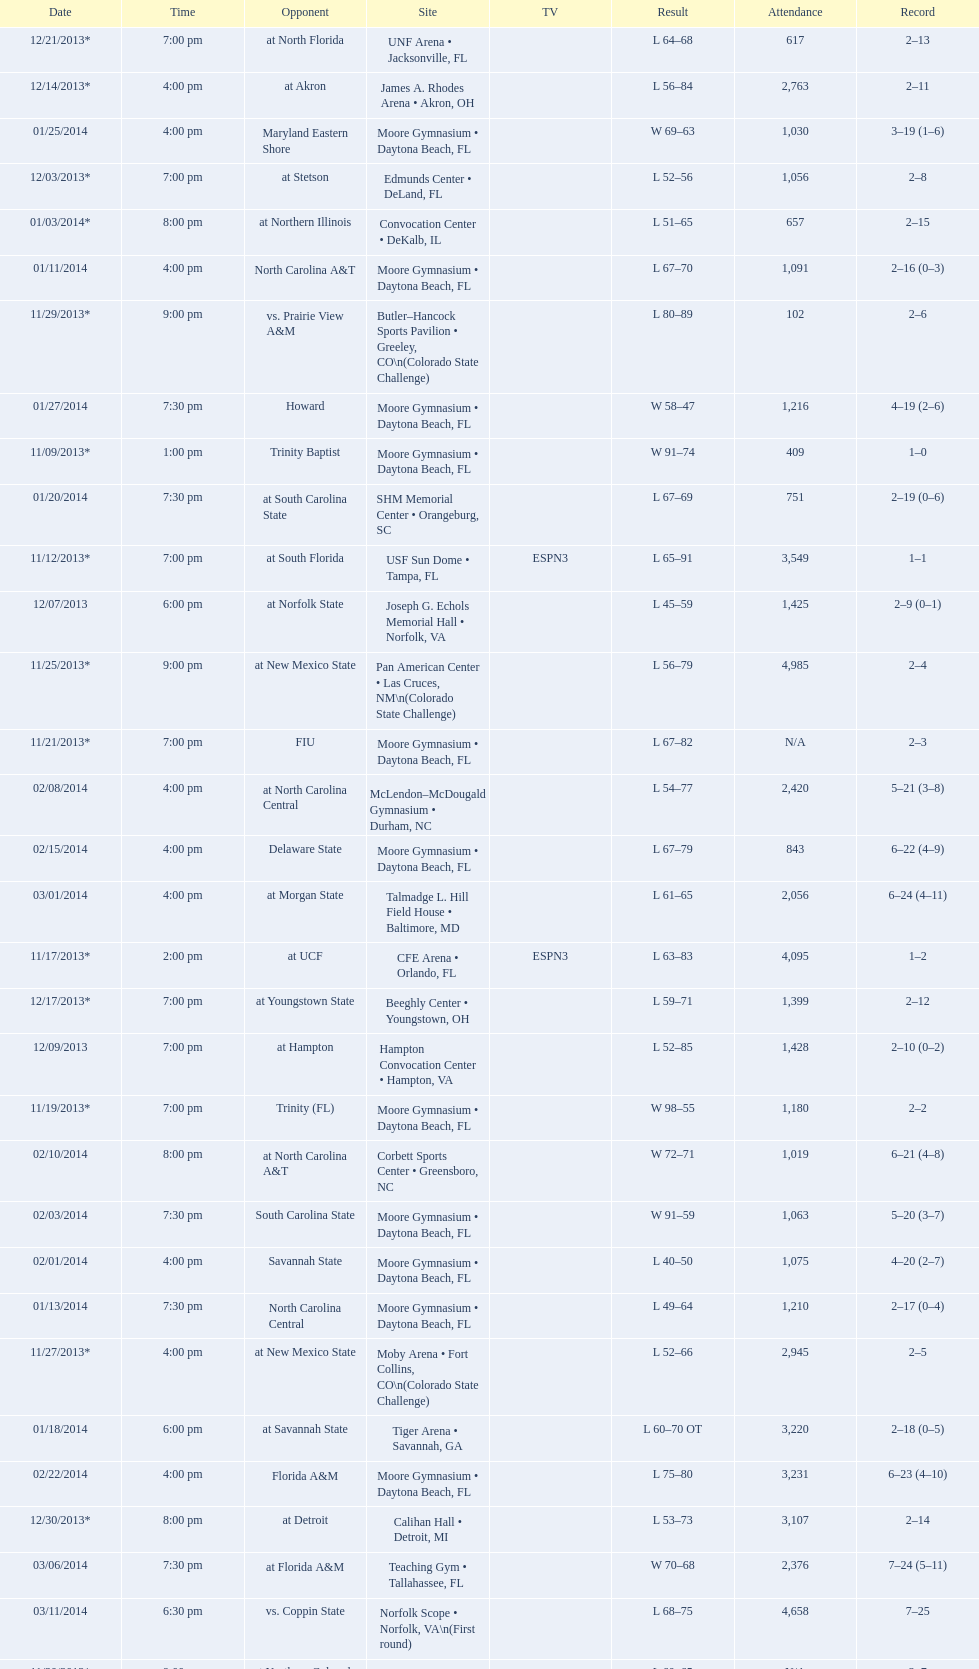What is the total attendance on 11/09/2013? 409. Help me parse the entirety of this table. {'header': ['Date', 'Time', 'Opponent', 'Site', 'TV', 'Result', 'Attendance', 'Record'], 'rows': [['12/21/2013*', '7:00 pm', 'at\xa0North Florida', 'UNF Arena • Jacksonville, FL', '', 'L\xa064–68', '617', '2–13'], ['12/14/2013*', '4:00 pm', 'at\xa0Akron', 'James A. Rhodes Arena • Akron, OH', '', 'L\xa056–84', '2,763', '2–11'], ['01/25/2014', '4:00 pm', 'Maryland Eastern Shore', 'Moore Gymnasium • Daytona Beach, FL', '', 'W\xa069–63', '1,030', '3–19 (1–6)'], ['12/03/2013*', '7:00 pm', 'at\xa0Stetson', 'Edmunds Center • DeLand, FL', '', 'L\xa052–56', '1,056', '2–8'], ['01/03/2014*', '8:00 pm', 'at\xa0Northern Illinois', 'Convocation Center • DeKalb, IL', '', 'L\xa051–65', '657', '2–15'], ['01/11/2014', '4:00 pm', 'North Carolina A&T', 'Moore Gymnasium • Daytona Beach, FL', '', 'L\xa067–70', '1,091', '2–16 (0–3)'], ['11/29/2013*', '9:00 pm', 'vs.\xa0Prairie View A&M', 'Butler–Hancock Sports Pavilion • Greeley, CO\\n(Colorado State Challenge)', '', 'L\xa080–89', '102', '2–6'], ['01/27/2014', '7:30 pm', 'Howard', 'Moore Gymnasium • Daytona Beach, FL', '', 'W\xa058–47', '1,216', '4–19 (2–6)'], ['11/09/2013*', '1:00 pm', 'Trinity Baptist', 'Moore Gymnasium • Daytona Beach, FL', '', 'W\xa091–74', '409', '1–0'], ['01/20/2014', '7:30 pm', 'at\xa0South Carolina State', 'SHM Memorial Center • Orangeburg, SC', '', 'L\xa067–69', '751', '2–19 (0–6)'], ['11/12/2013*', '7:00 pm', 'at\xa0South Florida', 'USF Sun Dome • Tampa, FL', 'ESPN3', 'L\xa065–91', '3,549', '1–1'], ['12/07/2013', '6:00 pm', 'at\xa0Norfolk State', 'Joseph G. Echols Memorial Hall • Norfolk, VA', '', 'L\xa045–59', '1,425', '2–9 (0–1)'], ['11/25/2013*', '9:00 pm', 'at\xa0New Mexico State', 'Pan American Center • Las Cruces, NM\\n(Colorado State Challenge)', '', 'L\xa056–79', '4,985', '2–4'], ['11/21/2013*', '7:00 pm', 'FIU', 'Moore Gymnasium • Daytona Beach, FL', '', 'L\xa067–82', 'N/A', '2–3'], ['02/08/2014', '4:00 pm', 'at\xa0North Carolina Central', 'McLendon–McDougald Gymnasium • Durham, NC', '', 'L\xa054–77', '2,420', '5–21 (3–8)'], ['02/15/2014', '4:00 pm', 'Delaware State', 'Moore Gymnasium • Daytona Beach, FL', '', 'L\xa067–79', '843', '6–22 (4–9)'], ['03/01/2014', '4:00 pm', 'at\xa0Morgan State', 'Talmadge L. Hill Field House • Baltimore, MD', '', 'L\xa061–65', '2,056', '6–24 (4–11)'], ['11/17/2013*', '2:00 pm', 'at\xa0UCF', 'CFE Arena • Orlando, FL', 'ESPN3', 'L\xa063–83', '4,095', '1–2'], ['12/17/2013*', '7:00 pm', 'at\xa0Youngstown State', 'Beeghly Center • Youngstown, OH', '', 'L\xa059–71', '1,399', '2–12'], ['12/09/2013', '7:00 pm', 'at\xa0Hampton', 'Hampton Convocation Center • Hampton, VA', '', 'L\xa052–85', '1,428', '2–10 (0–2)'], ['11/19/2013*', '7:00 pm', 'Trinity (FL)', 'Moore Gymnasium • Daytona Beach, FL', '', 'W\xa098–55', '1,180', '2–2'], ['02/10/2014', '8:00 pm', 'at\xa0North Carolina A&T', 'Corbett Sports Center • Greensboro, NC', '', 'W\xa072–71', '1,019', '6–21 (4–8)'], ['02/03/2014', '7:30 pm', 'South Carolina State', 'Moore Gymnasium • Daytona Beach, FL', '', 'W\xa091–59', '1,063', '5–20 (3–7)'], ['02/01/2014', '4:00 pm', 'Savannah State', 'Moore Gymnasium • Daytona Beach, FL', '', 'L\xa040–50', '1,075', '4–20 (2–7)'], ['01/13/2014', '7:30 pm', 'North Carolina Central', 'Moore Gymnasium • Daytona Beach, FL', '', 'L\xa049–64', '1,210', '2–17 (0–4)'], ['11/27/2013*', '4:00 pm', 'at\xa0New Mexico State', 'Moby Arena • Fort Collins, CO\\n(Colorado State Challenge)', '', 'L\xa052–66', '2,945', '2–5'], ['01/18/2014', '6:00 pm', 'at\xa0Savannah State', 'Tiger Arena • Savannah, GA', '', 'L\xa060–70\xa0OT', '3,220', '2–18 (0–5)'], ['02/22/2014', '4:00 pm', 'Florida A&M', 'Moore Gymnasium • Daytona Beach, FL', '', 'L\xa075–80', '3,231', '6–23 (4–10)'], ['12/30/2013*', '8:00 pm', 'at\xa0Detroit', 'Calihan Hall • Detroit, MI', '', 'L\xa053–73', '3,107', '2–14'], ['03/06/2014', '7:30 pm', 'at\xa0Florida A&M', 'Teaching Gym • Tallahassee, FL', '', 'W\xa070–68', '2,376', '7–24 (5–11)'], ['03/11/2014', '6:30 pm', 'vs.\xa0Coppin State', 'Norfolk Scope • Norfolk, VA\\n(First round)', '', 'L\xa068–75', '4,658', '7–25'], ['11/30/2013*', '9:00 pm', 'at\xa0Northern Colorado', 'Butler–Hancock Sports Pavilion • Greeley, CO\\n(Colorado State Challenge)', '', 'L\xa060–65', 'N/A', '2–7']]} 